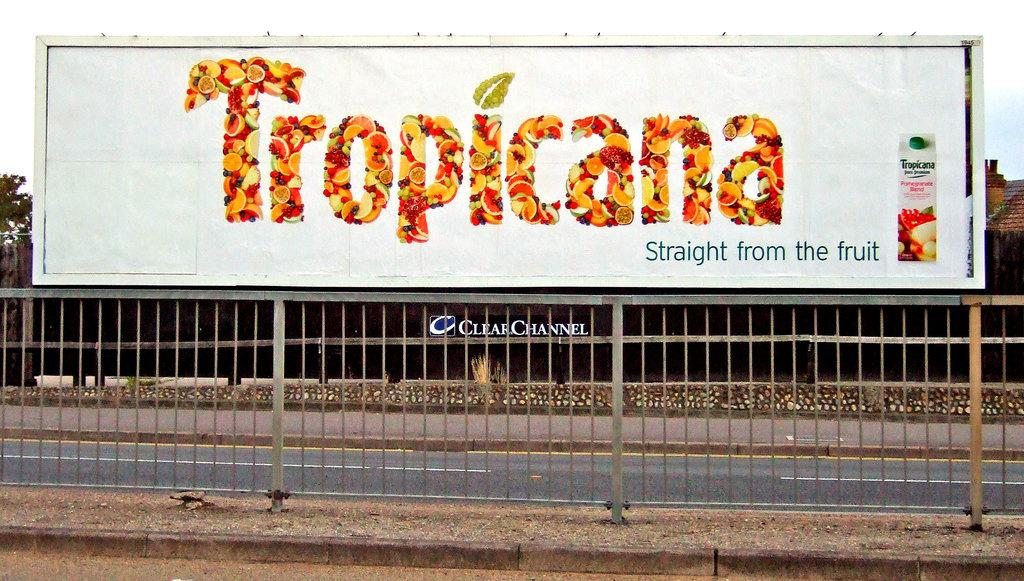<image>
Share a concise interpretation of the image provided. a Tropicana advertisement that is located outside in orange 